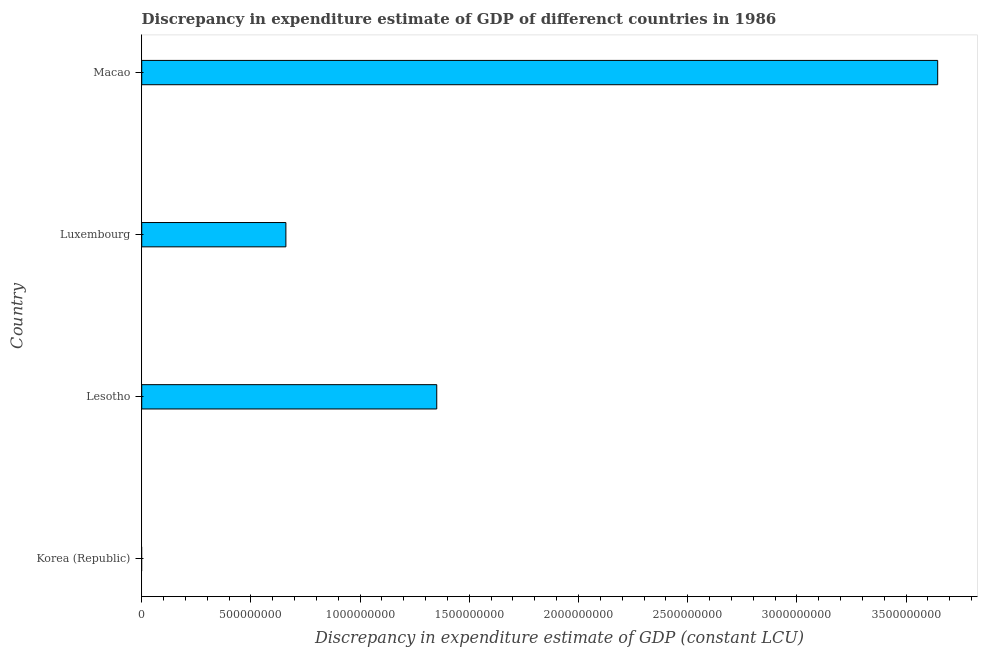Does the graph contain any zero values?
Offer a terse response. Yes. What is the title of the graph?
Your answer should be very brief. Discrepancy in expenditure estimate of GDP of differenct countries in 1986. What is the label or title of the X-axis?
Provide a short and direct response. Discrepancy in expenditure estimate of GDP (constant LCU). What is the label or title of the Y-axis?
Your answer should be compact. Country. What is the discrepancy in expenditure estimate of gdp in Luxembourg?
Ensure brevity in your answer.  6.60e+08. Across all countries, what is the maximum discrepancy in expenditure estimate of gdp?
Provide a short and direct response. 3.64e+09. Across all countries, what is the minimum discrepancy in expenditure estimate of gdp?
Give a very brief answer. 0. In which country was the discrepancy in expenditure estimate of gdp maximum?
Provide a short and direct response. Macao. What is the sum of the discrepancy in expenditure estimate of gdp?
Ensure brevity in your answer.  5.66e+09. What is the difference between the discrepancy in expenditure estimate of gdp in Lesotho and Luxembourg?
Give a very brief answer. 6.91e+08. What is the average discrepancy in expenditure estimate of gdp per country?
Provide a succinct answer. 1.41e+09. What is the median discrepancy in expenditure estimate of gdp?
Your response must be concise. 1.01e+09. What is the ratio of the discrepancy in expenditure estimate of gdp in Luxembourg to that in Macao?
Your answer should be very brief. 0.18. Is the discrepancy in expenditure estimate of gdp in Lesotho less than that in Luxembourg?
Give a very brief answer. No. Is the difference between the discrepancy in expenditure estimate of gdp in Lesotho and Macao greater than the difference between any two countries?
Provide a short and direct response. No. What is the difference between the highest and the second highest discrepancy in expenditure estimate of gdp?
Provide a succinct answer. 2.29e+09. Is the sum of the discrepancy in expenditure estimate of gdp in Lesotho and Luxembourg greater than the maximum discrepancy in expenditure estimate of gdp across all countries?
Offer a terse response. No. What is the difference between the highest and the lowest discrepancy in expenditure estimate of gdp?
Ensure brevity in your answer.  3.64e+09. In how many countries, is the discrepancy in expenditure estimate of gdp greater than the average discrepancy in expenditure estimate of gdp taken over all countries?
Provide a short and direct response. 1. How many bars are there?
Give a very brief answer. 3. Are all the bars in the graph horizontal?
Offer a terse response. Yes. How many countries are there in the graph?
Make the answer very short. 4. What is the difference between two consecutive major ticks on the X-axis?
Your answer should be very brief. 5.00e+08. Are the values on the major ticks of X-axis written in scientific E-notation?
Keep it short and to the point. No. What is the Discrepancy in expenditure estimate of GDP (constant LCU) of Korea (Republic)?
Ensure brevity in your answer.  0. What is the Discrepancy in expenditure estimate of GDP (constant LCU) of Lesotho?
Offer a very short reply. 1.35e+09. What is the Discrepancy in expenditure estimate of GDP (constant LCU) in Luxembourg?
Keep it short and to the point. 6.60e+08. What is the Discrepancy in expenditure estimate of GDP (constant LCU) of Macao?
Ensure brevity in your answer.  3.64e+09. What is the difference between the Discrepancy in expenditure estimate of GDP (constant LCU) in Lesotho and Luxembourg?
Offer a terse response. 6.91e+08. What is the difference between the Discrepancy in expenditure estimate of GDP (constant LCU) in Lesotho and Macao?
Provide a succinct answer. -2.29e+09. What is the difference between the Discrepancy in expenditure estimate of GDP (constant LCU) in Luxembourg and Macao?
Offer a very short reply. -2.98e+09. What is the ratio of the Discrepancy in expenditure estimate of GDP (constant LCU) in Lesotho to that in Luxembourg?
Give a very brief answer. 2.05. What is the ratio of the Discrepancy in expenditure estimate of GDP (constant LCU) in Lesotho to that in Macao?
Provide a short and direct response. 0.37. What is the ratio of the Discrepancy in expenditure estimate of GDP (constant LCU) in Luxembourg to that in Macao?
Give a very brief answer. 0.18. 